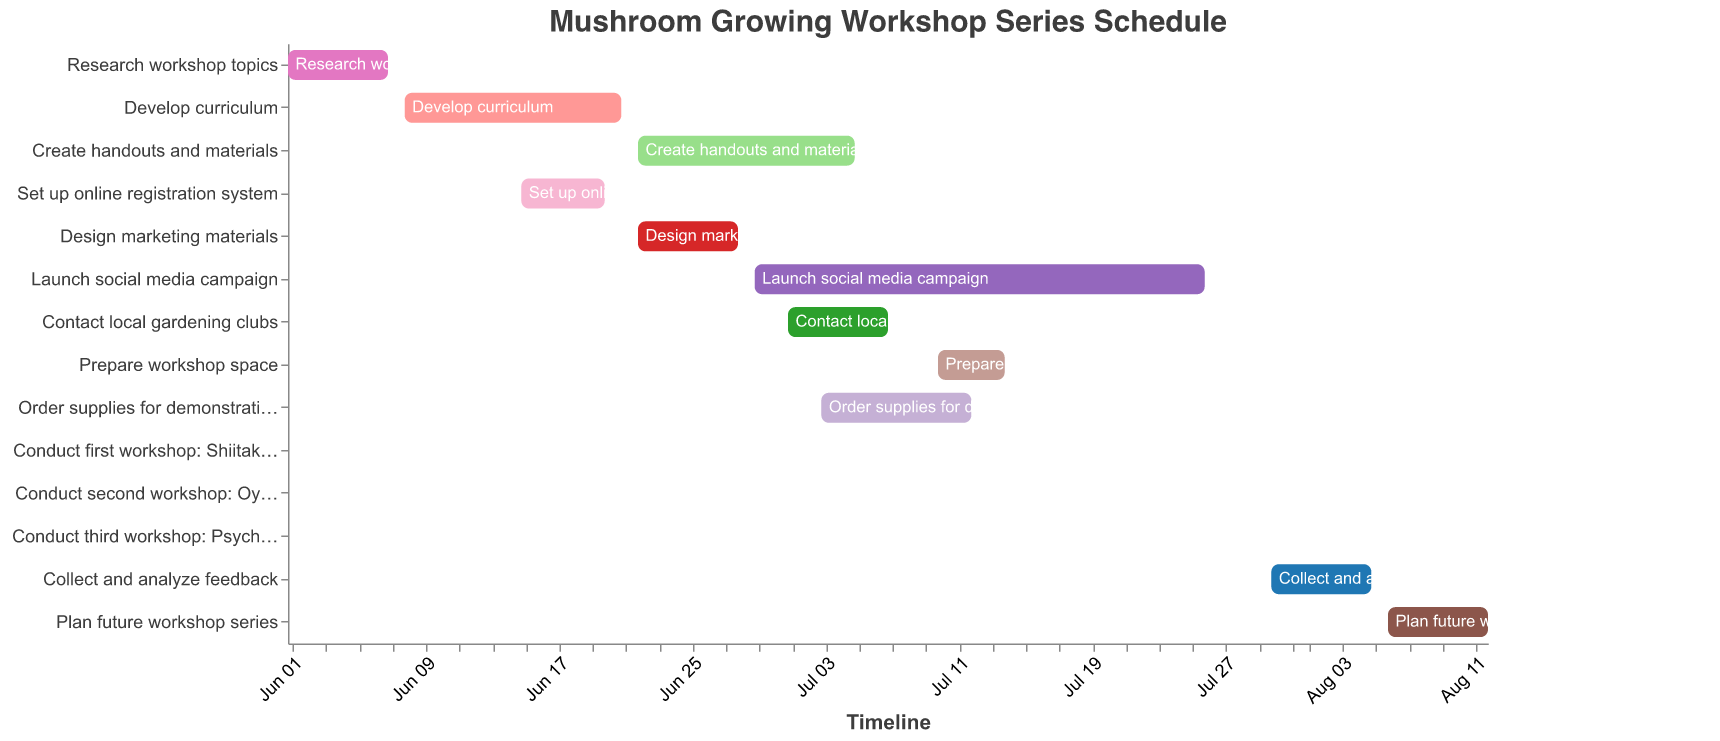What's the title of the Gantt chart? The title of a chart is typically found at the top of the figure and directly states the purpose or content being visualized. In this case, it is "Mushroom Growing Workshop Series Schedule".
Answer: Mushroom Growing Workshop Series Schedule How long does the "Develop curriculum" task last? To determine the duration of the task, find the start and end dates and calculate the number of days between them. The "Develop curriculum" task starts on 2023-06-08 and ends on 2023-06-21, which makes it 14 days.
Answer: 14 days Which tasks overlap with the "Create handouts and materials" task? To find overlapping tasks, look at their start and end dates relative to the "Create handouts and materials" task (2023-06-22 to 2023-07-05). The overlapping tasks are "Design marketing materials" (2023-06-22 to 2023-06-28) and "Launch social media campaign" (2023-06-29 to 2023-07-26).
Answer: Design marketing materials, Launch social media campaign What task is scheduled to finish first? Find the task with the earliest end date by examining the chart data. "Research workshop topics" ends on 2023-06-07, the earliest among all tasks.
Answer: Research workshop topics How many tasks are scheduled to start in July? Count the number of tasks that start within the month of July. They are "Contact local gardening clubs" (2023-07-01), "Order supplies for demonstrations" (2023-07-03), "Prepare workshop space" (2023-07-10), "Conduct first workshop: Shiitake cultivation" (2023-07-15), "Conduct second workshop: Oyster mushroom growing" (2023-07-22), and "Conduct third workshop: Psychedelic mushroom identification" (2023-07-29).
Answer: 6 Which task has the longest duration? Calculate the duration of each task by finding the difference between the start and end dates, then identify the task with the longest duration. The "Launch social media campaign" lasts from 2023-06-29 to 2023-07-26, making it 28 days, the longest duration of all tasks.
Answer: Launch social media campaign When is the "Conduct third workshop: Psychedelic mushroom identification" scheduled? To determine the date for this task, find the entry in the Gantt chart which states, "Conduct third workshop: Psychedelic mushroom identification". This task is scheduled for 2023-07-29.
Answer: 2023-07-29 How many workshops are conducted in total? Count the number of tasks that start with "Conduct workshop". There are three such tasks: "Conduct first workshop: Shiitake cultivation", "Conduct second workshop: Oyster mushroom growing", and "Conduct third workshop: Psychedelic mushroom identification".
Answer: 3 Which tasks follow the "Prepare workshop space" task? Identify the task "Prepare workshop space" and then look for the subsequent tasks in the timeline. The tasks that follow are "Conduct first workshop: Shiitake cultivation" (2023-07-15), "Conduct second workshop: Oyster mushroom growing" (2023-07-22), "Conduct third workshop: Psychedelic mushroom identification" (2023-07-29), "Collect and analyze feedback" (2023-07-30 to 2023-08-05), and "Plan future workshop series" (2023-08-06 to 2023-08-12).
Answer: Conduct first workshop: Shiitake cultivation, Conduct second workshop: Oyster mushroom growing, Conduct third workshop: Psychedelic mushroom identification, Collect and analyze feedback, Plan future workshop series When does the task "Set up online registration system" take place? Look for the "Set up online registration system" entry in the Gantt chart to find the timeline. This task is scheduled from 2023-06-15 to 2023-06-20.
Answer: 2023-06-15 to 2023-06-20 